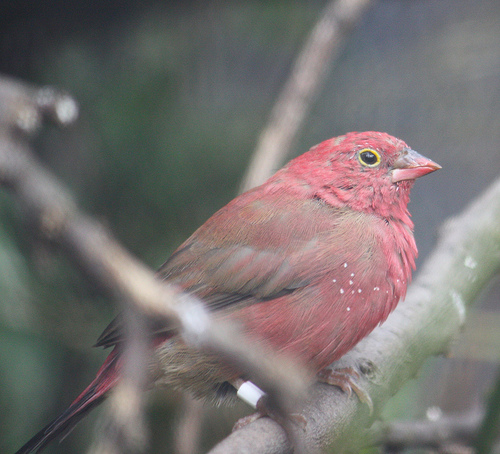<image>
Can you confirm if the branch is in front of the bird? Yes. The branch is positioned in front of the bird, appearing closer to the camera viewpoint. 